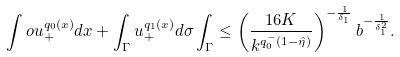<formula> <loc_0><loc_0><loc_500><loc_500>\int o u _ { + } ^ { q _ { 0 } ( x ) } d x + \int _ { \Gamma } u _ { + } ^ { q _ { 1 } ( x ) } d \sigma \int _ { \Gamma } \leq \left ( \frac { 1 6 K } { k ^ { q _ { 0 } ^ { - } ( 1 - \hat { \eta } ) } } \right ) ^ { - \frac { 1 } { \delta _ { 1 } } } b ^ { - \frac { 1 } { \delta _ { 1 } ^ { 2 } } } .</formula> 